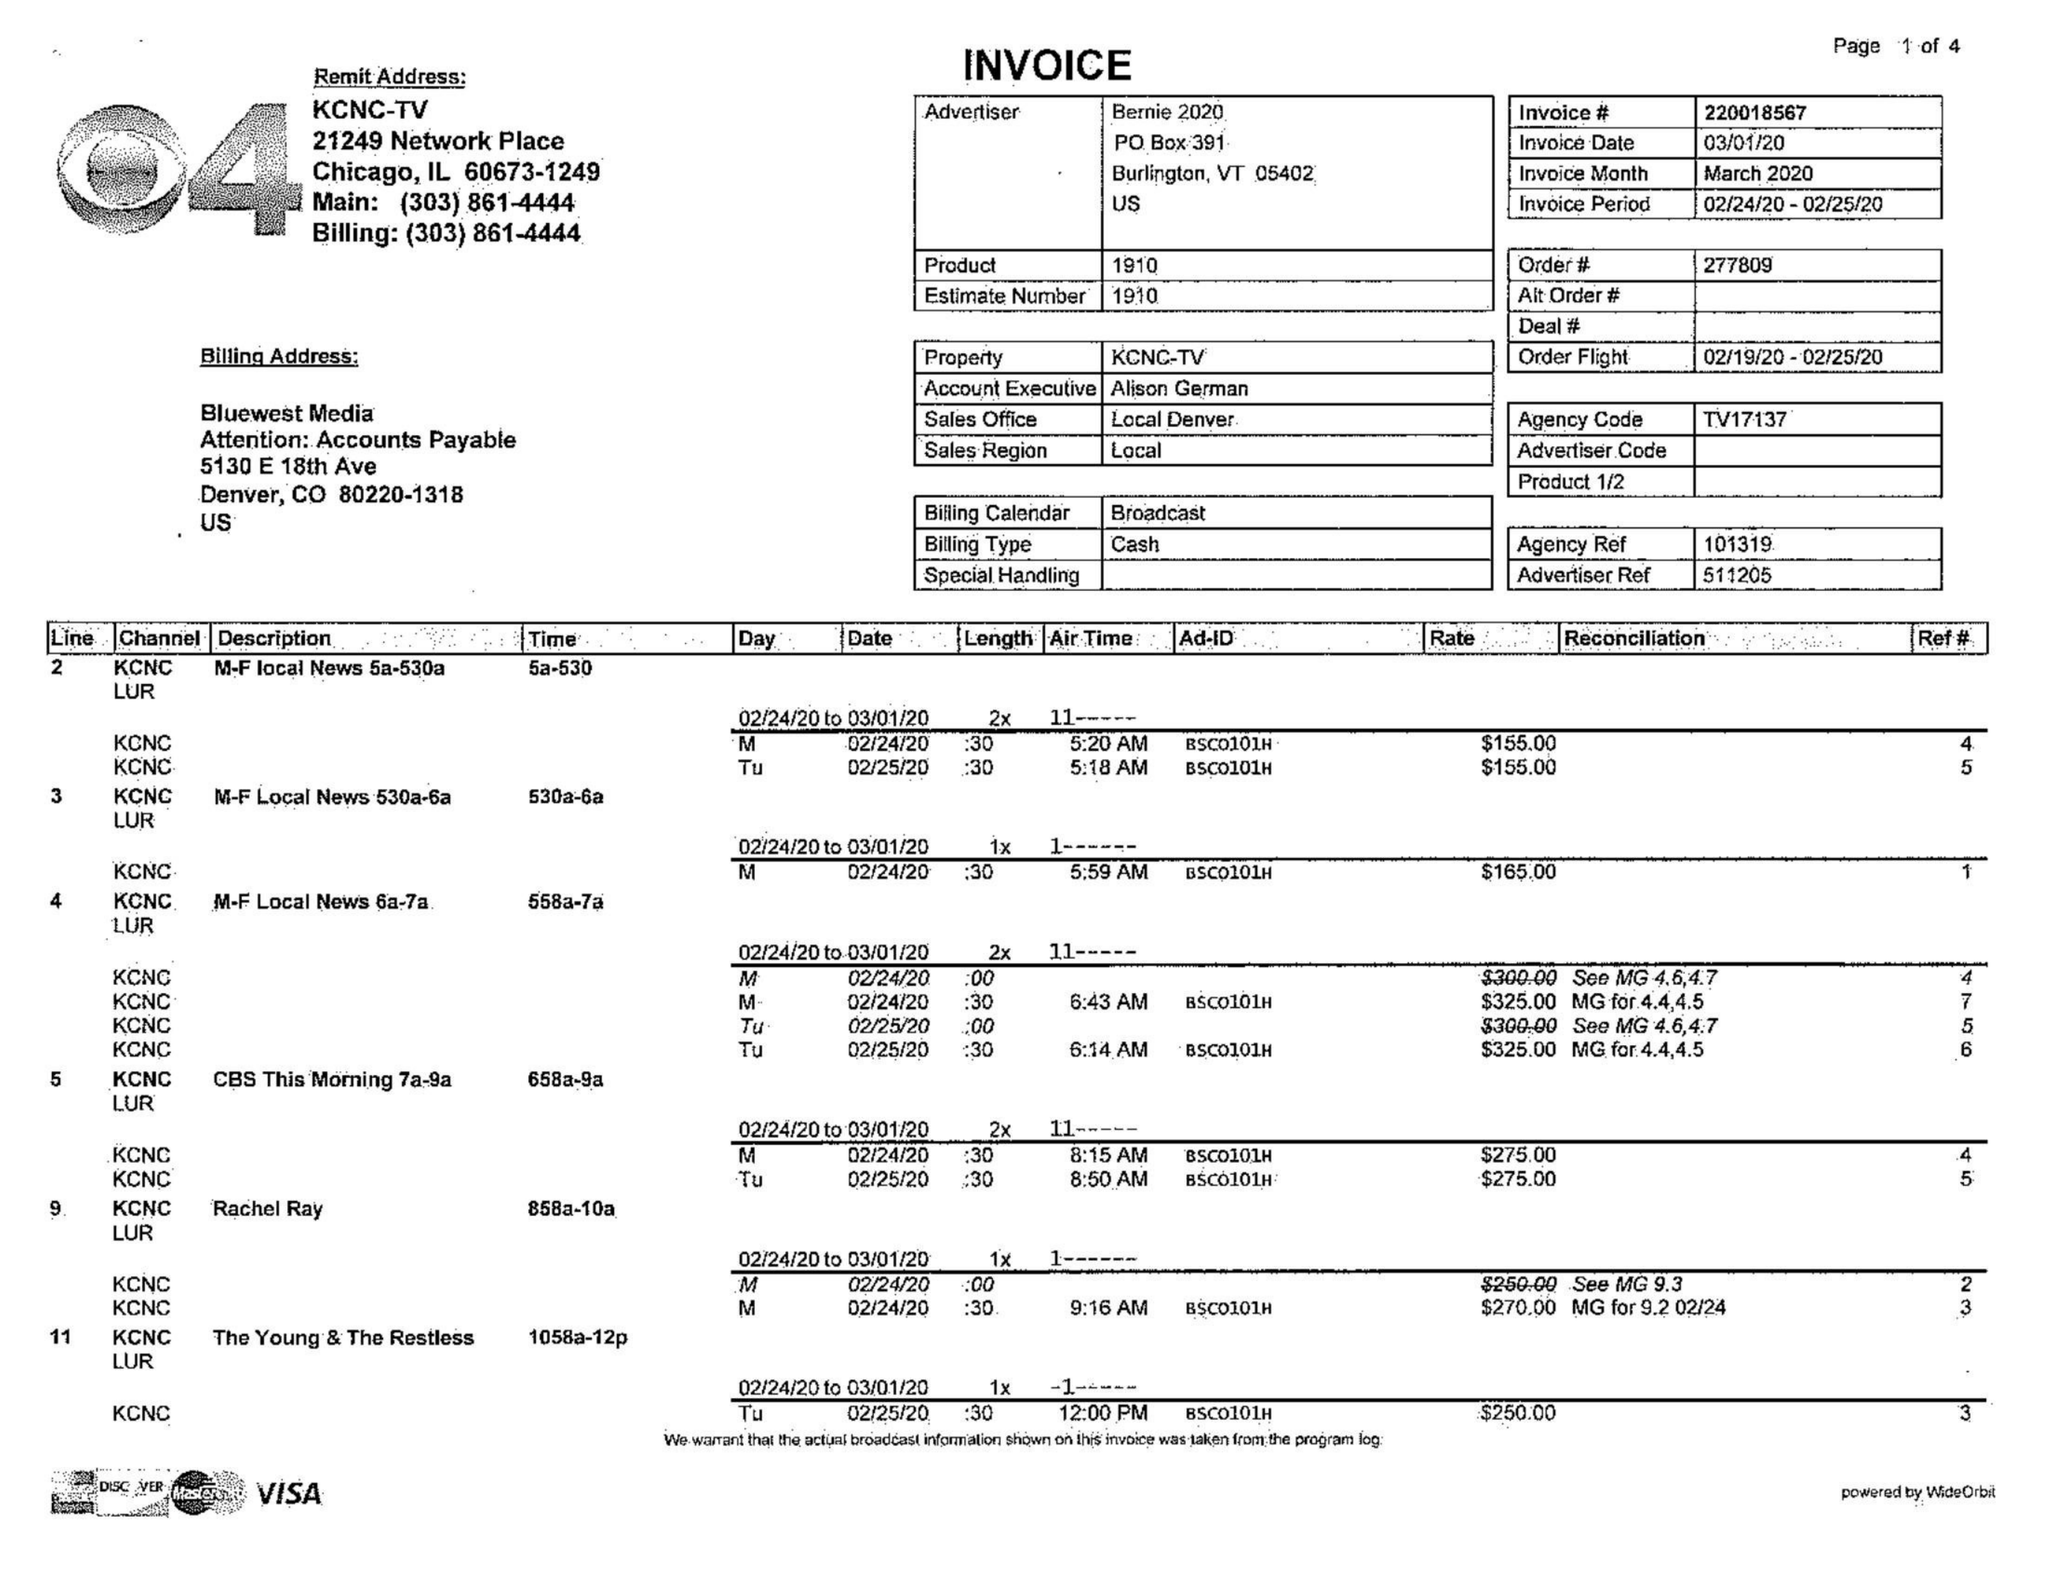What is the value for the advertiser?
Answer the question using a single word or phrase. BERNIE 2020 